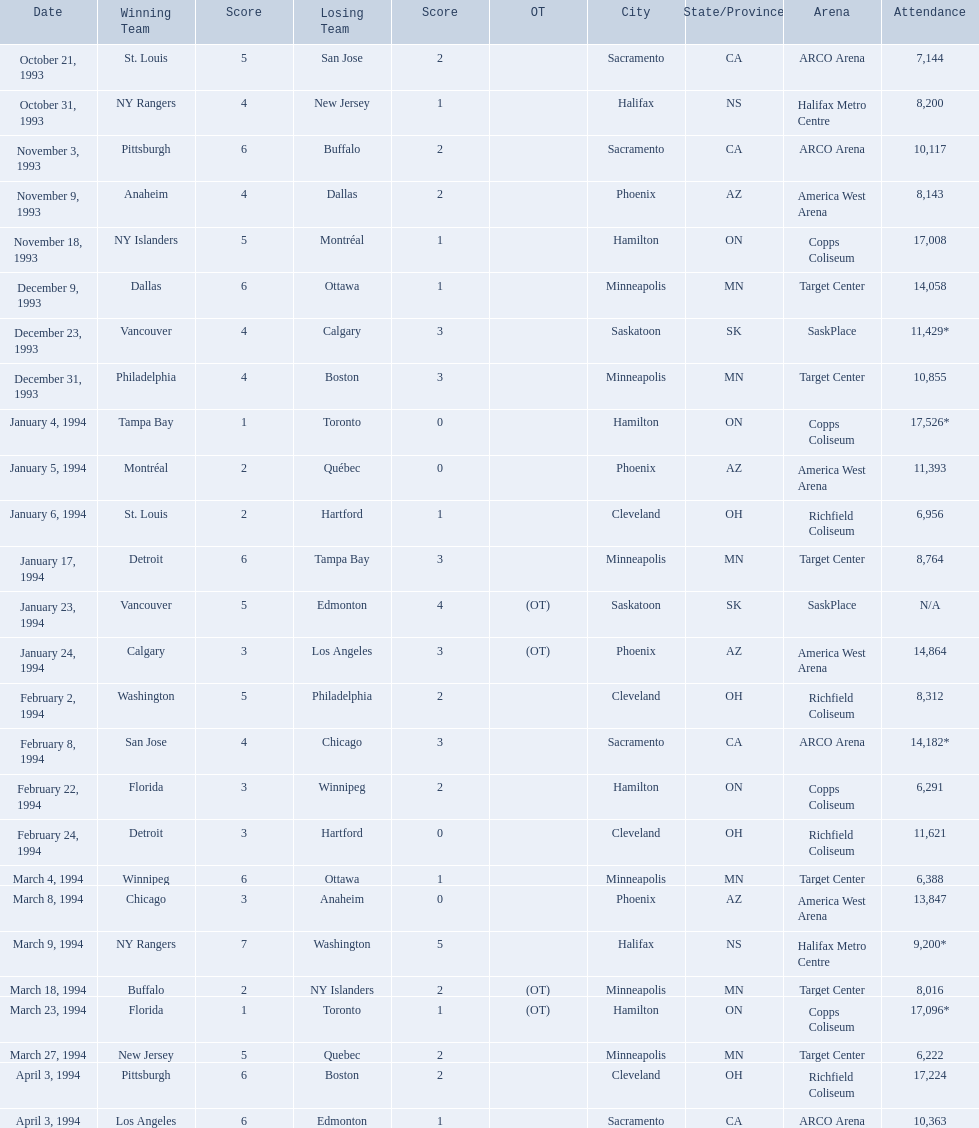Which was the highest attendance for a game? 17,526*. What was the date of the game with an attendance of 17,526? January 4, 1994. When were the competitions held? October 21, 1993, October 31, 1993, November 3, 1993, November 9, 1993, November 18, 1993, December 9, 1993, December 23, 1993, December 31, 1993, January 4, 1994, January 5, 1994, January 6, 1994, January 17, 1994, January 23, 1994, January 24, 1994, February 2, 1994, February 8, 1994, February 22, 1994, February 24, 1994, March 4, 1994, March 8, 1994, March 9, 1994, March 18, 1994, March 23, 1994, March 27, 1994, April 3, 1994, April 3, 1994. What was the audience size for those competitions? 7,144, 8,200, 10,117, 8,143, 17,008, 14,058, 11,429*, 10,855, 17,526*, 11,393, 6,956, 8,764, N/A, 14,864, 8,312, 14,182*, 6,291, 11,621, 6,388, 13,847, 9,200*, 8,016, 17,096*, 6,222, 17,224, 10,363. Which day had the greatest number of attendees? January 4, 1994. On which dates did the victorious team score just one point? January 4, 1994, March 23, 1994. Among these two, which date had a larger audience? January 4, 1994. 